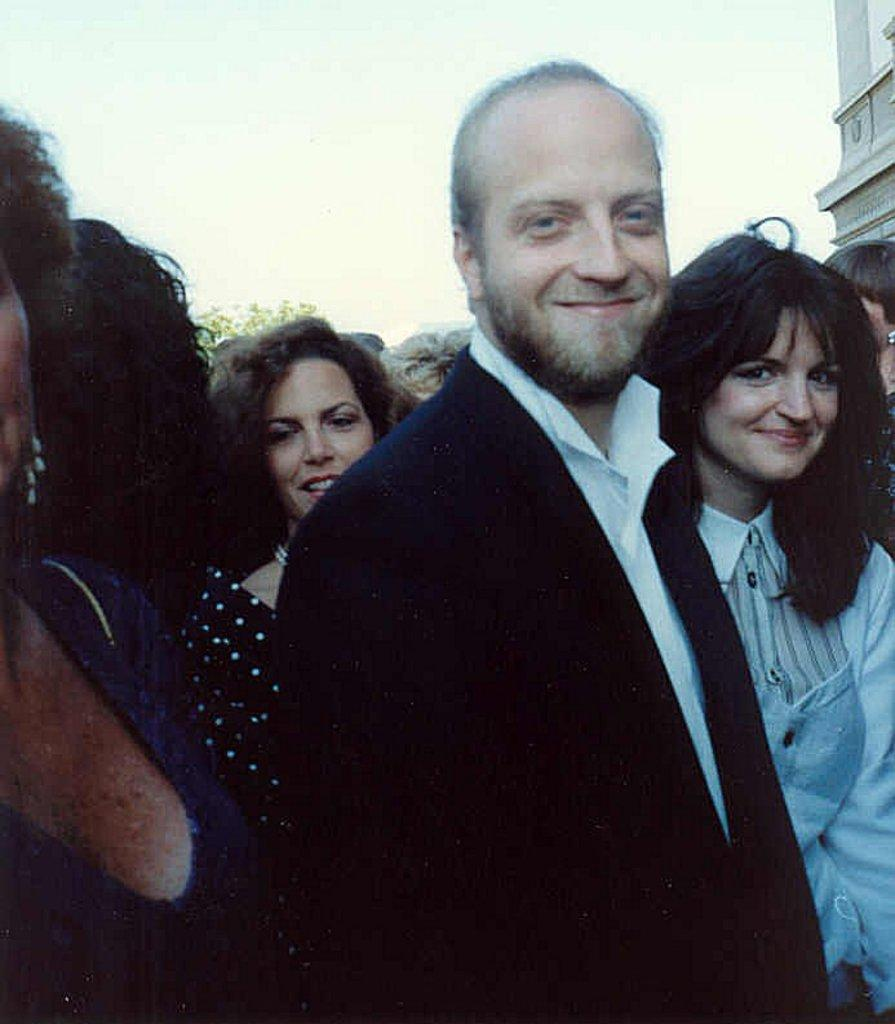What are the people in the image doing? The persons in the image are standing on the road. What can be seen in the background of the image? There is a sky and at least one building visible in the background of the image. What type of land can be seen in the image? The image does not show any specific type of land; it only shows a road, sky, and a building in the background. 